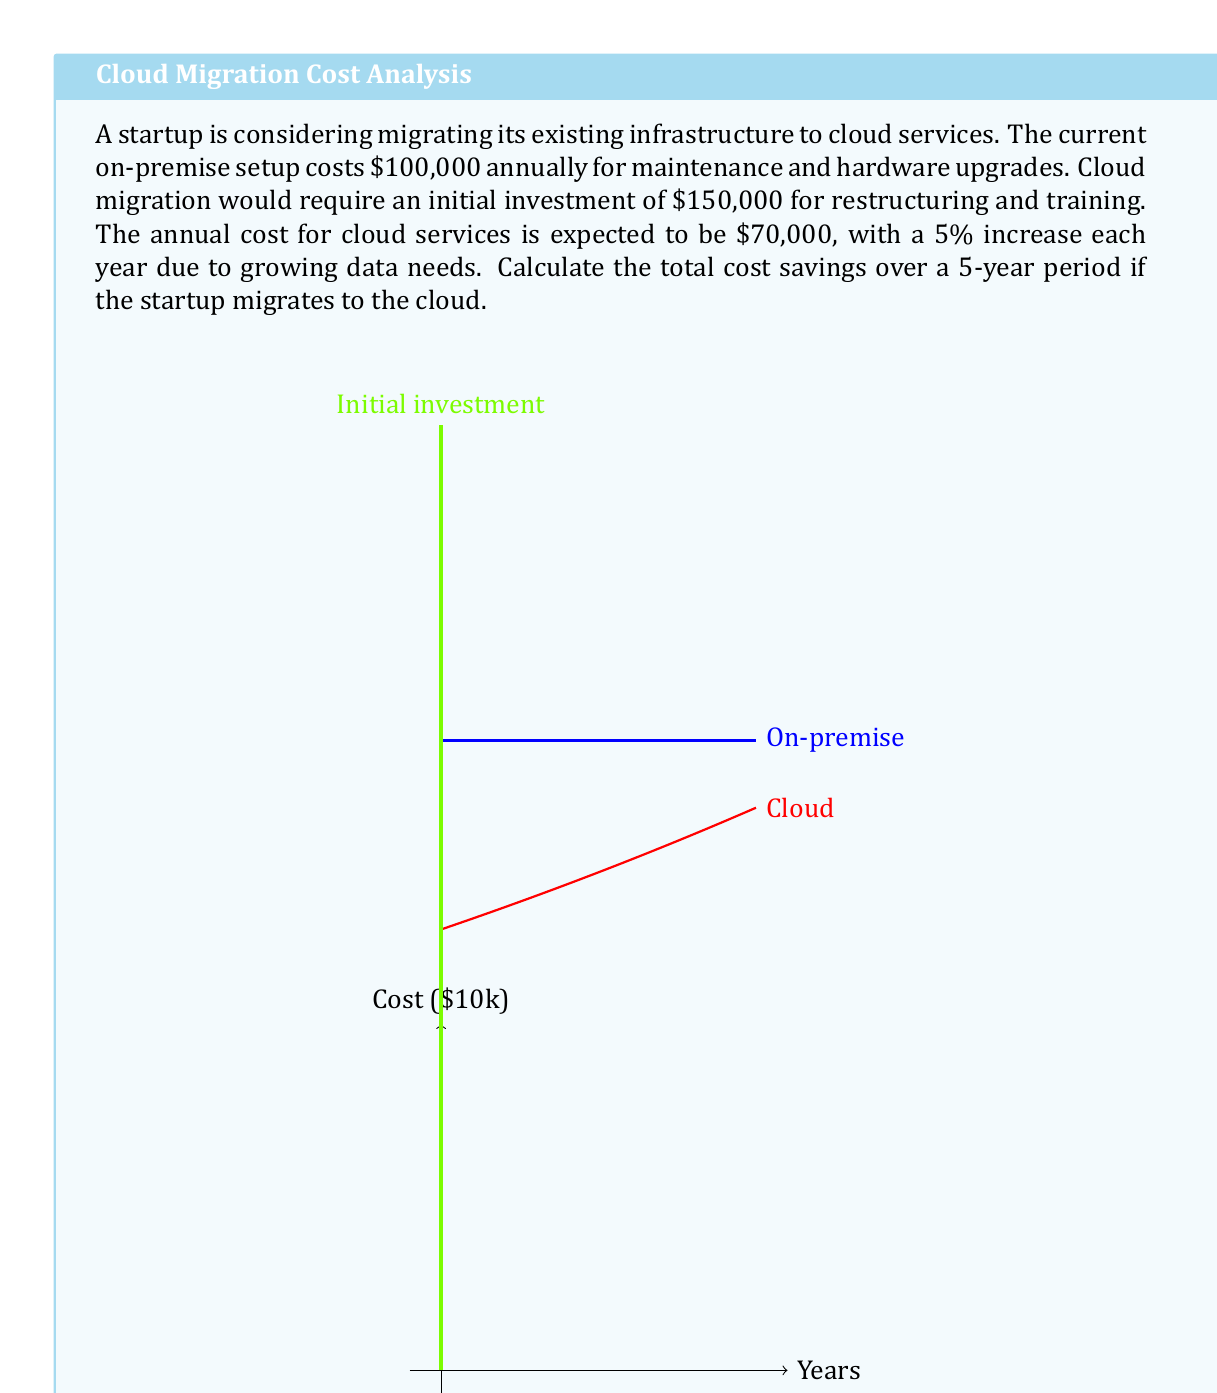Teach me how to tackle this problem. Let's break this down step-by-step:

1) On-premise costs over 5 years:
   $$5 \times $100,000 = $500,000$$

2) Cloud costs:
   - Initial investment: $150,000
   - Year 1: $70,000
   - Year 2: $70,000 \times 1.05 = $73,500
   - Year 3: $73,500 \times 1.05 = $77,175
   - Year 4: $77,175 \times 1.05 = $81,033.75
   - Year 5: $81,033.75 \times 1.05 = $85,085.44

3) Total cloud costs over 5 years:
   $$\begin{align}
   &$150,000 + $70,000 + $73,500 + $77,175 + $81,033.75 + $85,085.44 \\
   &= $536,794.19
   \end{align}$$

4) Cost savings:
   $$\begin{align}
   &\text{On-premise cost} - \text{Cloud cost} \\
   &= $500,000 - $536,794.19 \\
   &= -$36,794.19
   \end{align}$$

The negative result indicates that migrating to the cloud would actually cost more over the 5-year period.
Answer: -$36,794.19 